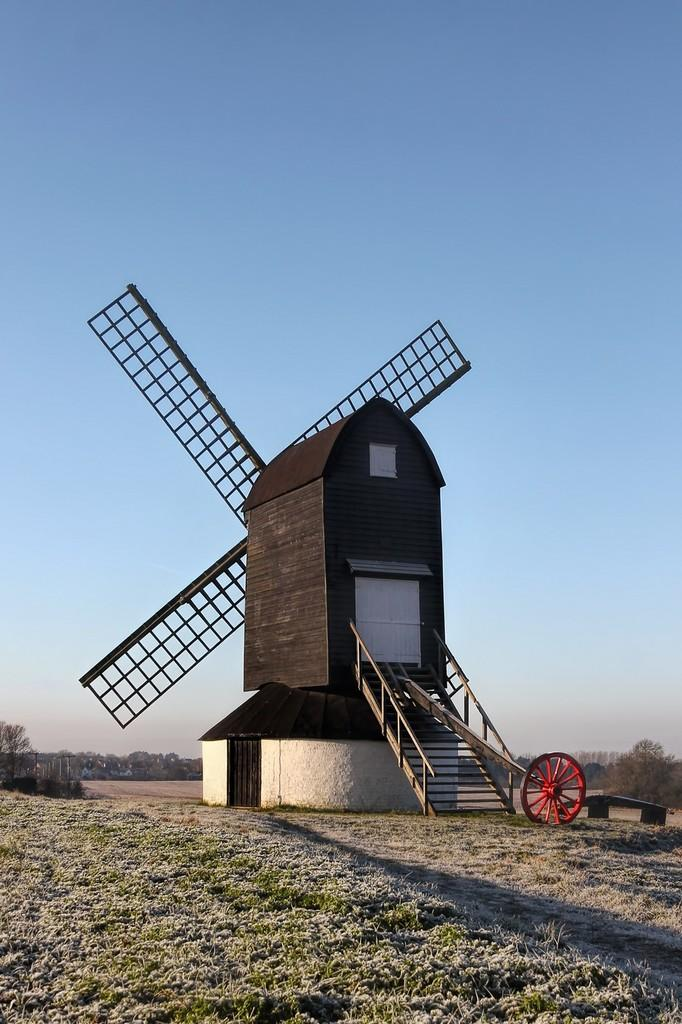What is the main subject in the center of the image? There is a windmill in the center of the image. What can be seen in the background of the image? There are trees in the background of the image. How many payments are required to operate the windmill in the image? There is no information about payments or operating the windmill in the image. Can you see a flock of birds flying near the windmill in the image? There is no mention of birds or a flock in the image; it only features a windmill and trees in the background. 